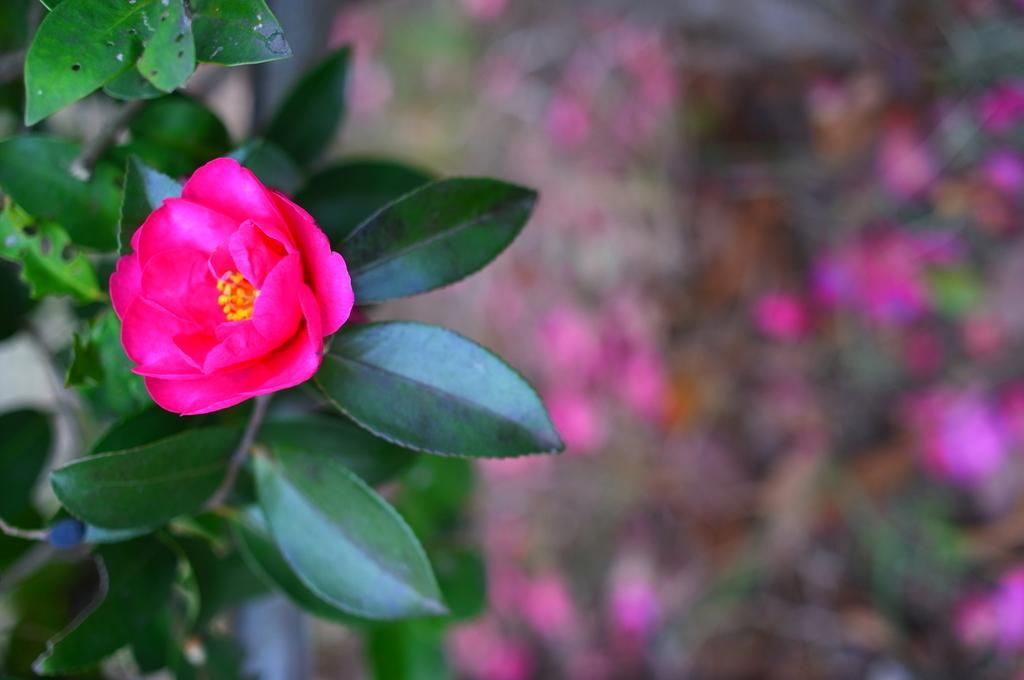Please provide a concise description of this image. In this image, we can see a plant with flower and the background is blurry. 